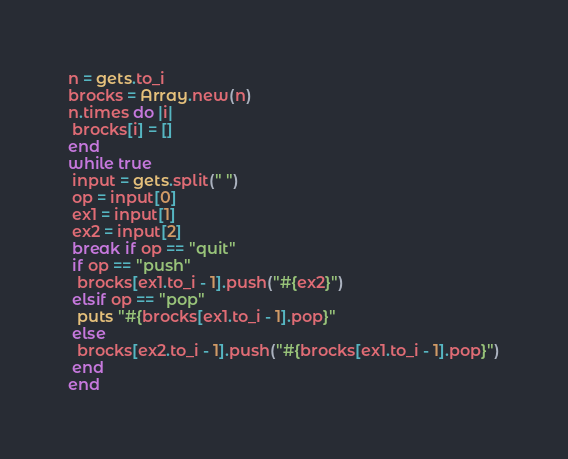<code> <loc_0><loc_0><loc_500><loc_500><_Ruby_>n = gets.to_i
brocks = Array.new(n)
n.times do |i|
 brocks[i] = []
end
while true
 input = gets.split(" ")
 op = input[0]
 ex1 = input[1]
 ex2 = input[2]
 break if op == "quit"
 if op == "push"
  brocks[ex1.to_i - 1].push("#{ex2}")
 elsif op == "pop"
  puts "#{brocks[ex1.to_i - 1].pop}"
 else
  brocks[ex2.to_i - 1].push("#{brocks[ex1.to_i - 1].pop}")
 end
end</code> 